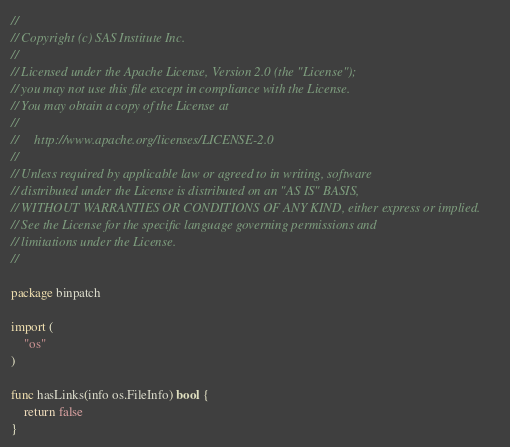<code> <loc_0><loc_0><loc_500><loc_500><_Go_>//
// Copyright (c) SAS Institute Inc.
//
// Licensed under the Apache License, Version 2.0 (the "License");
// you may not use this file except in compliance with the License.
// You may obtain a copy of the License at
//
//     http://www.apache.org/licenses/LICENSE-2.0
//
// Unless required by applicable law or agreed to in writing, software
// distributed under the License is distributed on an "AS IS" BASIS,
// WITHOUT WARRANTIES OR CONDITIONS OF ANY KIND, either express or implied.
// See the License for the specific language governing permissions and
// limitations under the License.
//

package binpatch

import (
	"os"
)

func hasLinks(info os.FileInfo) bool {
	return false
}
</code> 